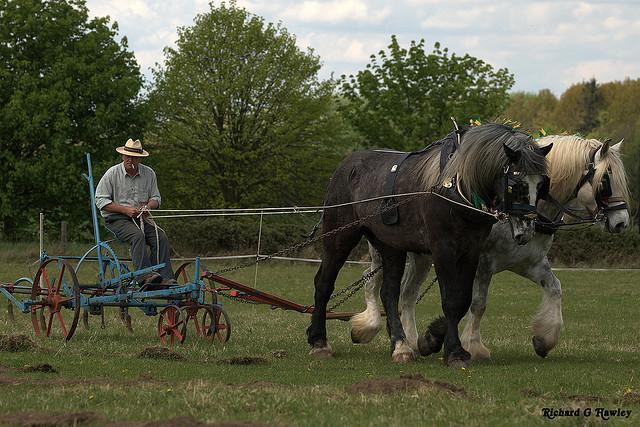What is he doing?
Choose the right answer from the provided options to respond to the question.
Options: Smoking cigarette, plowing field, stealing horsed, feeding horsed. Plowing field. 